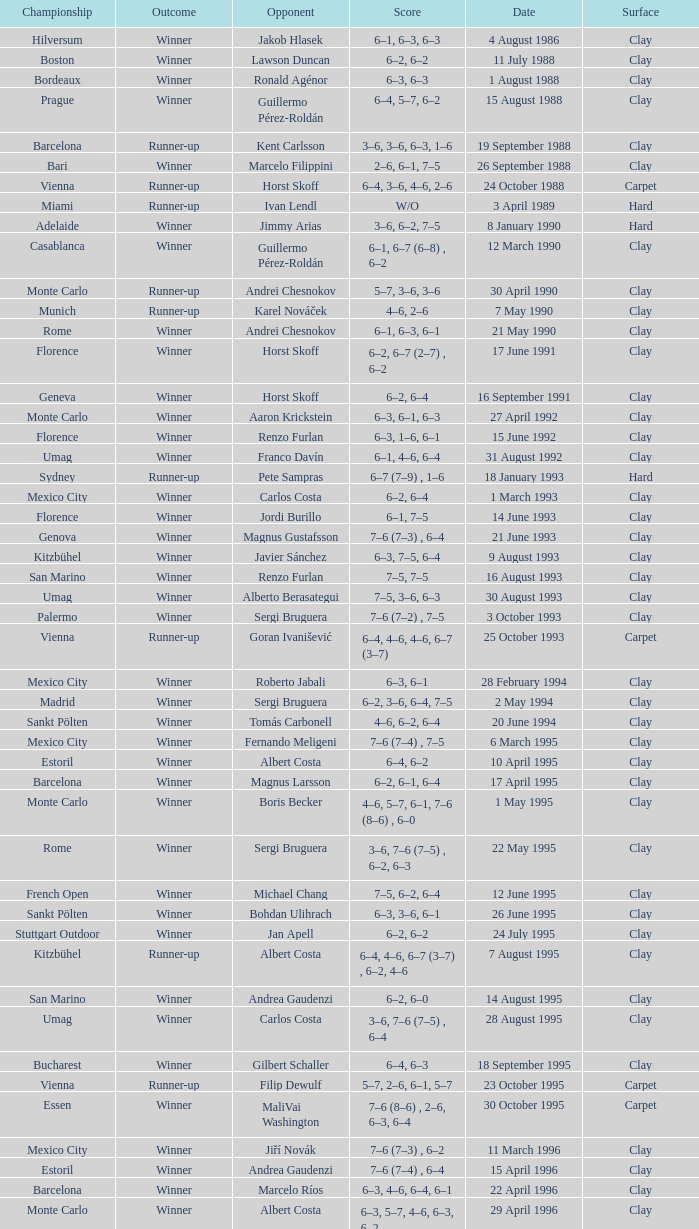Who is the opponent when the surface is clay, the outcome is winner and the championship is estoril on 15 april 1996? Andrea Gaudenzi. 